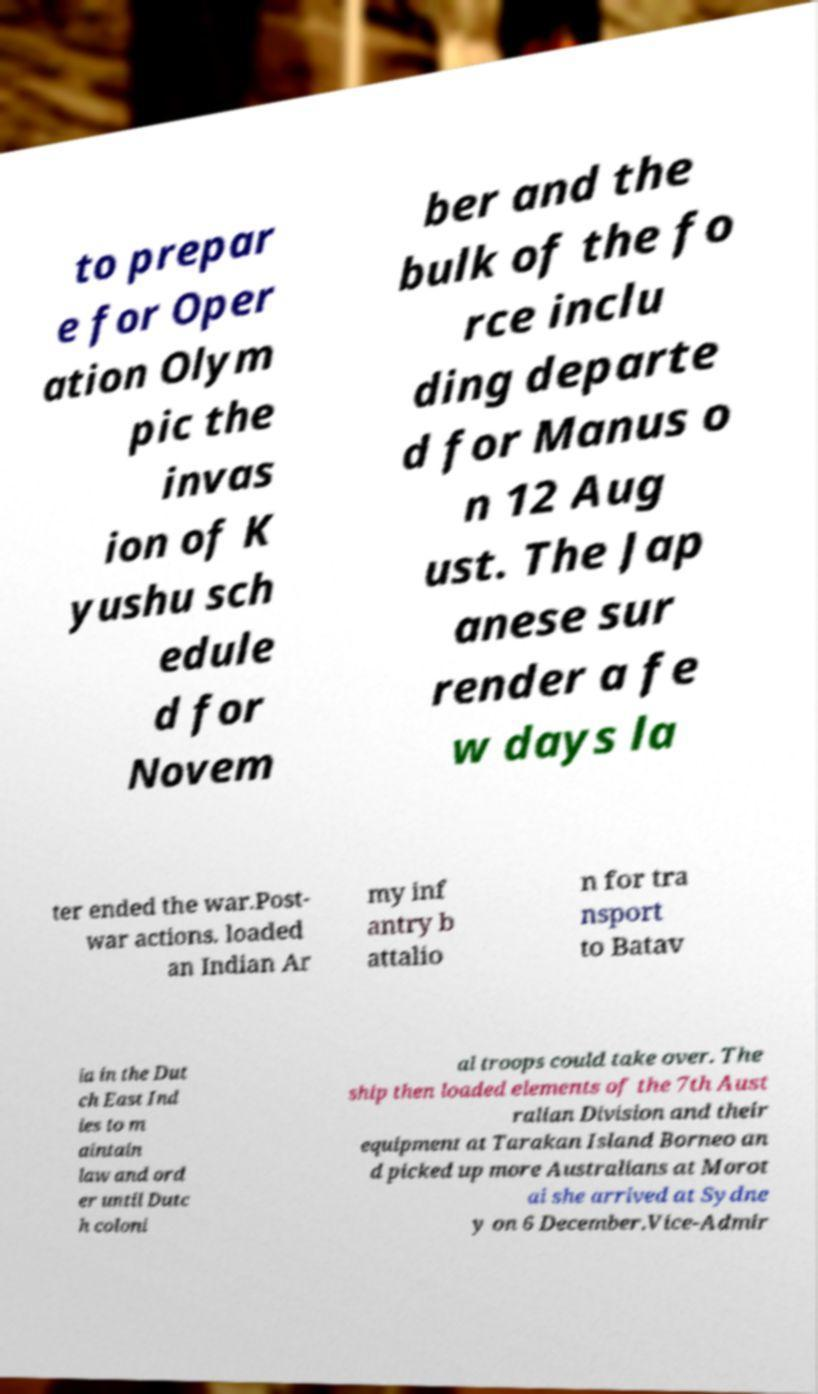For documentation purposes, I need the text within this image transcribed. Could you provide that? to prepar e for Oper ation Olym pic the invas ion of K yushu sch edule d for Novem ber and the bulk of the fo rce inclu ding departe d for Manus o n 12 Aug ust. The Jap anese sur render a fe w days la ter ended the war.Post- war actions. loaded an Indian Ar my inf antry b attalio n for tra nsport to Batav ia in the Dut ch East Ind ies to m aintain law and ord er until Dutc h coloni al troops could take over. The ship then loaded elements of the 7th Aust ralian Division and their equipment at Tarakan Island Borneo an d picked up more Australians at Morot ai she arrived at Sydne y on 6 December.Vice-Admir 